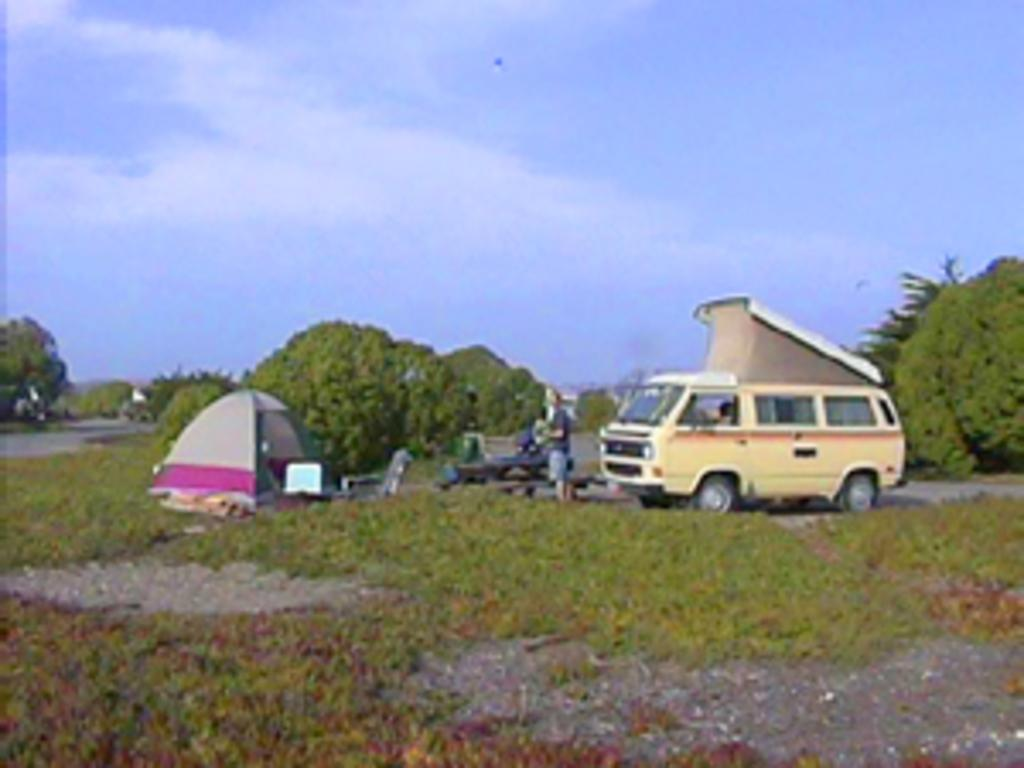What type of motor vehicle is on the ground in the image? The image does not specify the type of motor vehicle, but there is a motor vehicle on the ground. Who is present in the image besides the motor vehicle? There is a man standing in the image. What type of shelter is visible in the image? There is a tent in the image. What type of seating is available in the image? There are chairs in the image. What type of vegetation is present in the image? Grass, bushes, and trees are present in the image. What is visible in the sky in the image? The sky is visible in the image, and clouds are present in the sky. What time of day is it in the image, based on the hour? The image does not provide information about the time of day or the hour. Can you see a snake in the image? There is no snake present in the image. 